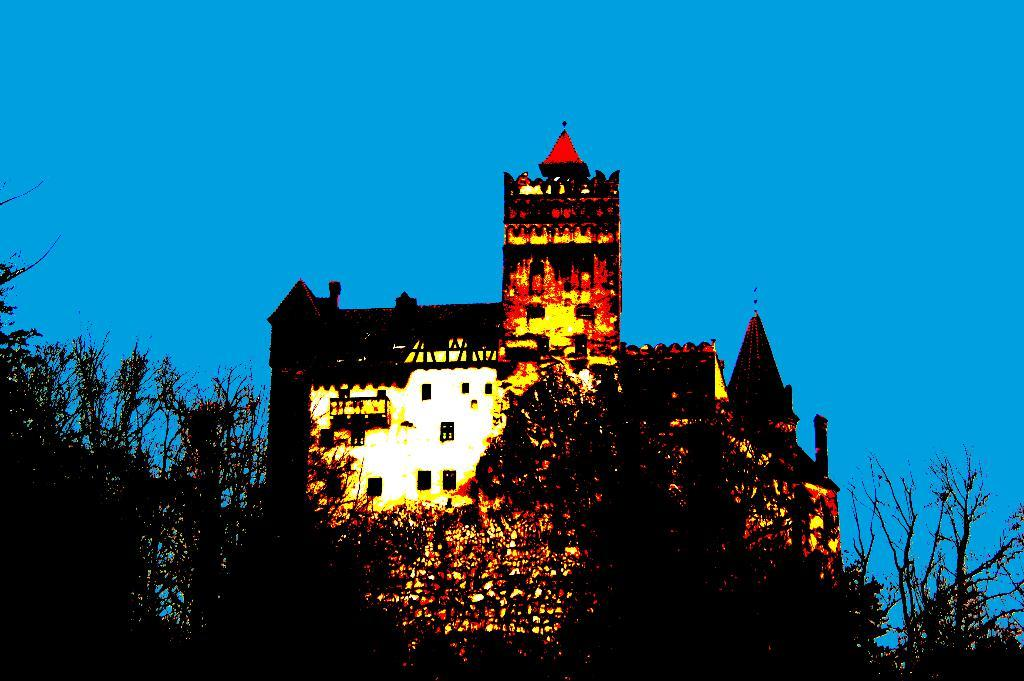What type of vegetation can be seen in the image? There are trees in the image. What type of structure is present in the image? There is a castle in the image. How would you describe the overall mood or atmosphere of the image? The image has a dark atmosphere. What color is the sky in the background of the image? The sky in the background is blue. Can you see any cherries growing on the trees in the image? There is no mention of cherries in the image, and the trees are not described in detail. What season is depicted in the image, given the presence of spring flowers? The image does not show any spring flowers or any indication of a specific season. 